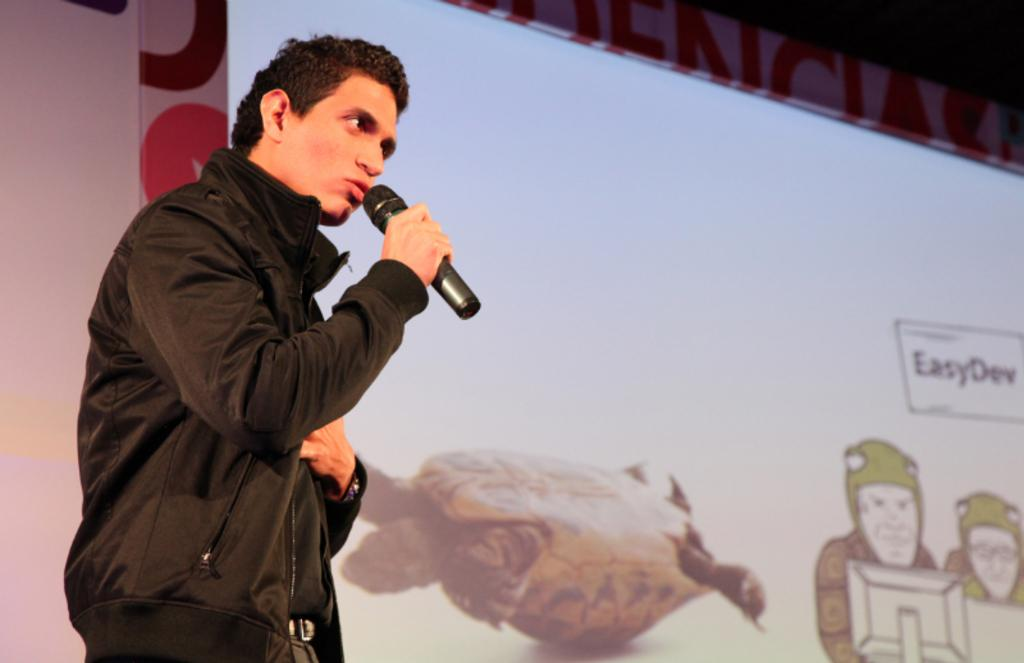What is the person on the right side of the image doing? The person is standing on the right side of the image and holding a microphone in his hand. What is the person doing with the microphone? The person is speaking into the microphone. What can be seen in the center of the image? There is a screen in the center of the image. What type of glove is the person wearing while speaking into the microphone? The person is not wearing any gloves in the image; they are simply holding the microphone with their hand. 